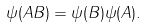Convert formula to latex. <formula><loc_0><loc_0><loc_500><loc_500>\psi ( A B ) = \psi ( B ) \psi ( A ) .</formula> 